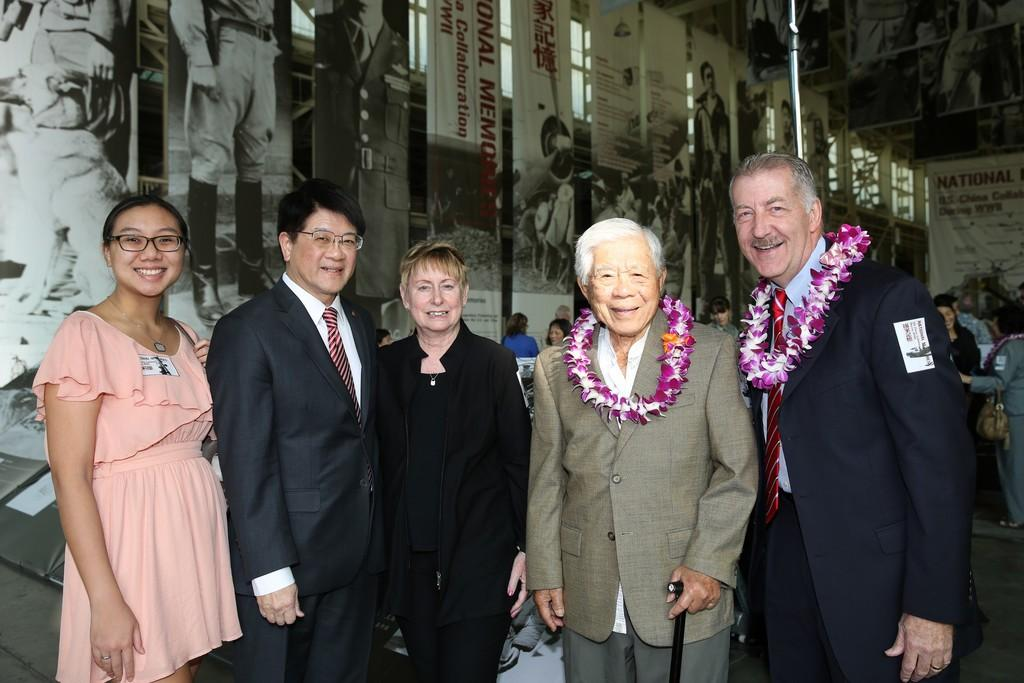What is happening in the center of the image? There are people standing in the center of the image. What can be seen on the wall in the background? There are banners on the wall in the background of the image. Are there any other people visible in the image? Yes, there are people in the background of the image to the right side. What decision was made by the camera in the afternoon? There is no camera present in the image, and therefore no decision can be attributed to it. 